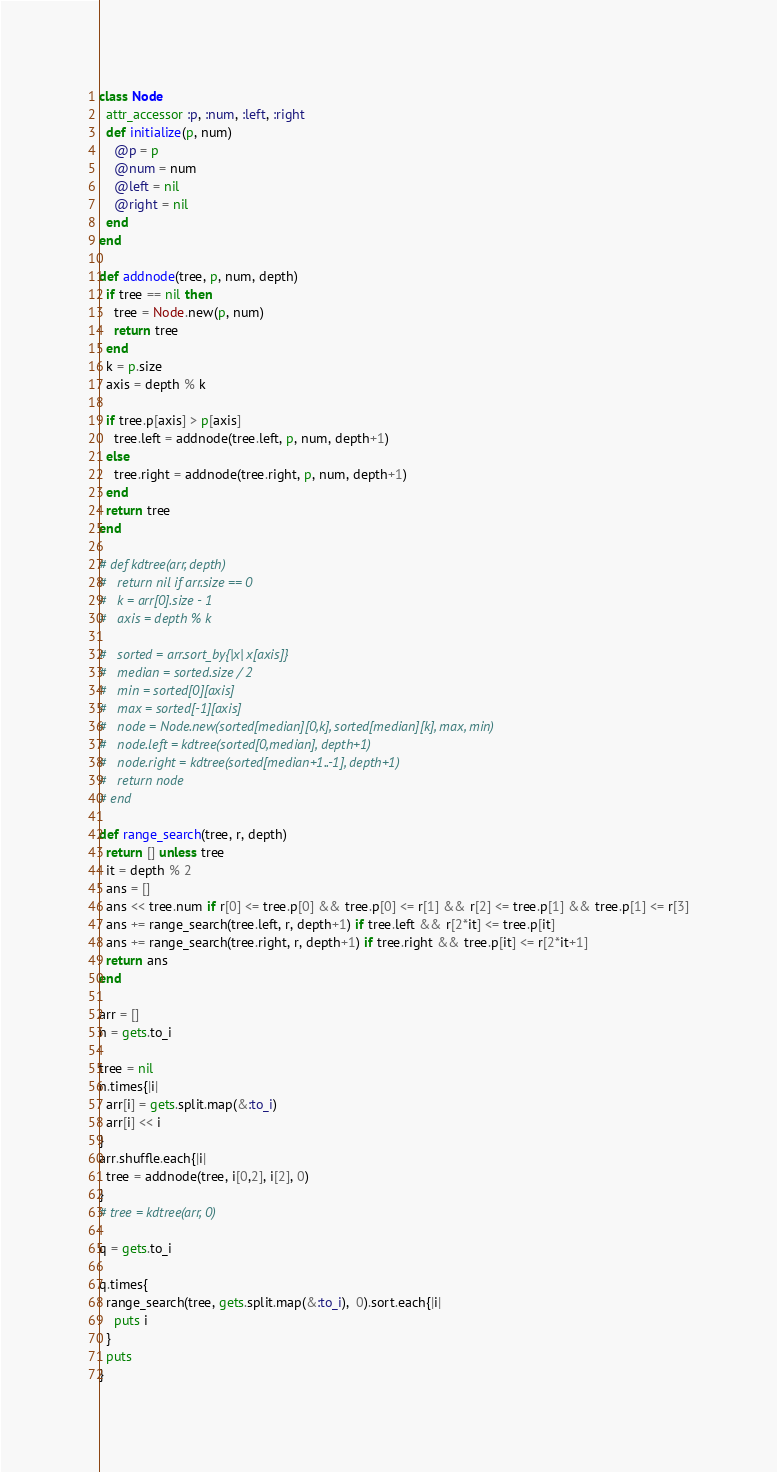<code> <loc_0><loc_0><loc_500><loc_500><_Ruby_>class Node
  attr_accessor :p, :num, :left, :right
  def initialize(p, num)
    @p = p
    @num = num
    @left = nil
    @right = nil
  end
end

def addnode(tree, p, num, depth)
  if tree == nil then
    tree = Node.new(p, num)
    return tree
  end
  k = p.size
  axis = depth % k

  if tree.p[axis] > p[axis]
    tree.left = addnode(tree.left, p, num, depth+1)
  else
    tree.right = addnode(tree.right, p, num, depth+1)
  end
  return tree
end

# def kdtree(arr, depth)
#   return nil if arr.size == 0
#   k = arr[0].size - 1
#   axis = depth % k

#   sorted = arr.sort_by{|x| x[axis]}
#   median = sorted.size / 2
#   min = sorted[0][axis]
#   max = sorted[-1][axis]
#   node = Node.new(sorted[median][0,k], sorted[median][k], max, min)
#   node.left = kdtree(sorted[0,median], depth+1)
#   node.right = kdtree(sorted[median+1..-1], depth+1)
#   return node
# end

def range_search(tree, r, depth)
  return [] unless tree
  it = depth % 2
  ans = []
  ans << tree.num if r[0] <= tree.p[0] && tree.p[0] <= r[1] && r[2] <= tree.p[1] && tree.p[1] <= r[3]
  ans += range_search(tree.left, r, depth+1) if tree.left && r[2*it] <= tree.p[it]
  ans += range_search(tree.right, r, depth+1) if tree.right && tree.p[it] <= r[2*it+1]
  return ans
end

arr = []
n = gets.to_i

tree = nil
n.times{|i|
  arr[i] = gets.split.map(&:to_i)
  arr[i] << i
}
arr.shuffle.each{|i|
  tree = addnode(tree, i[0,2], i[2], 0)
}
# tree = kdtree(arr, 0)

q = gets.to_i

q.times{
  range_search(tree, gets.split.map(&:to_i),  0).sort.each{|i|
    puts i
  }
  puts
}</code> 